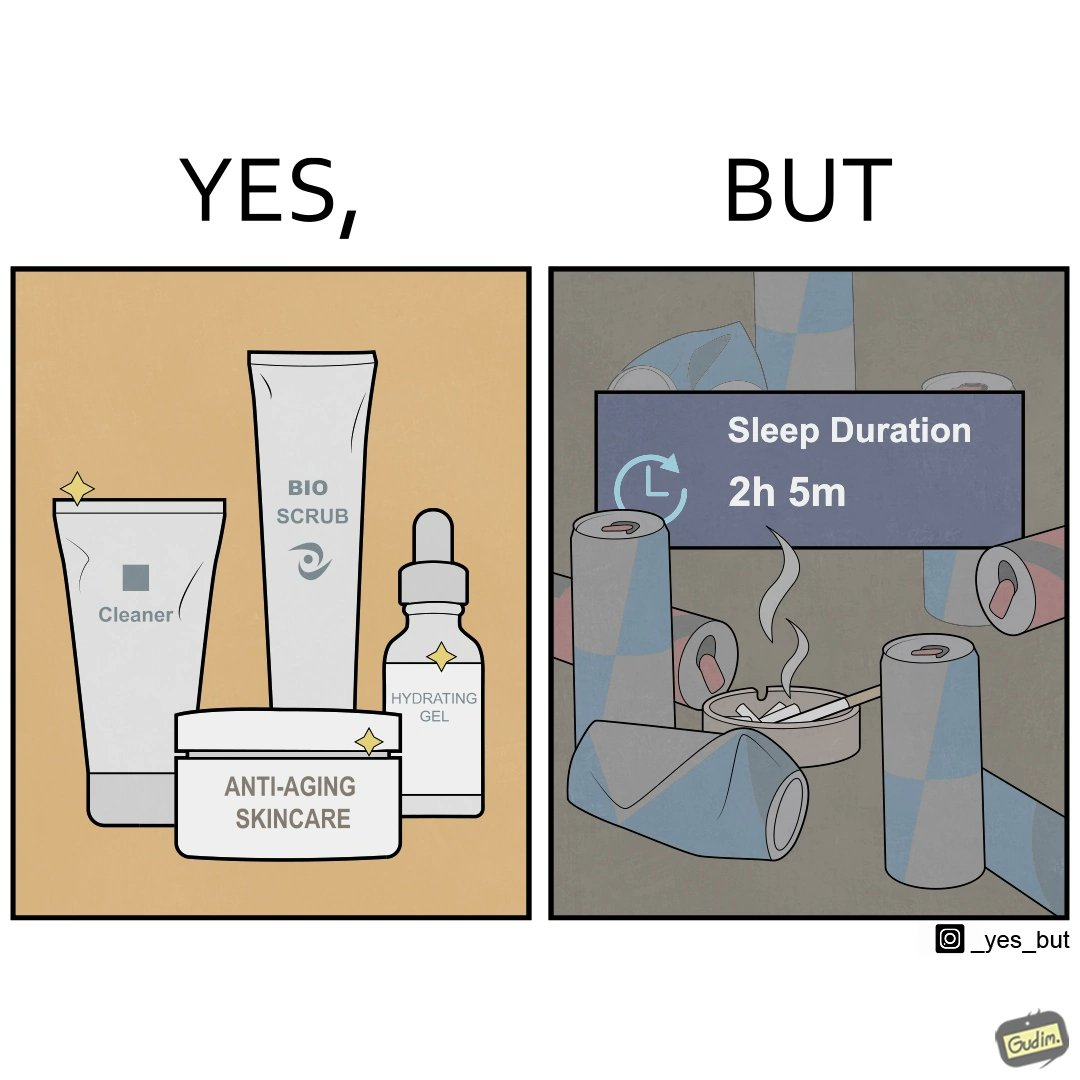Describe what you see in this image. This image is ironic as on the one hand, the presumed person is into skincare and wants to do the best for their skin, which is good, but on the other hand, they are involved in unhealthy habits that will damage their skin like smoking, caffeine and inadequate sleep. 